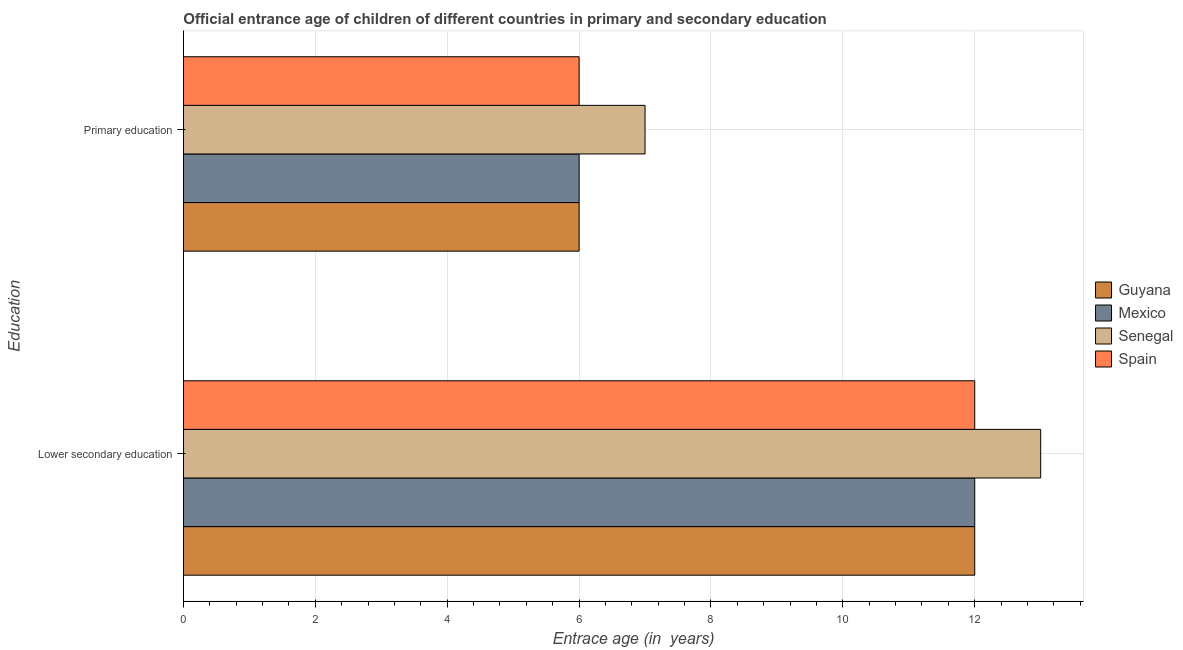How many groups of bars are there?
Offer a terse response. 2. Are the number of bars per tick equal to the number of legend labels?
Your response must be concise. Yes. What is the label of the 2nd group of bars from the top?
Provide a short and direct response. Lower secondary education. What is the entrance age of chiildren in primary education in Senegal?
Offer a terse response. 7. Across all countries, what is the maximum entrance age of children in lower secondary education?
Your answer should be compact. 13. Across all countries, what is the minimum entrance age of chiildren in primary education?
Ensure brevity in your answer.  6. In which country was the entrance age of chiildren in primary education maximum?
Your answer should be very brief. Senegal. In which country was the entrance age of chiildren in primary education minimum?
Make the answer very short. Guyana. What is the total entrance age of children in lower secondary education in the graph?
Your answer should be very brief. 49. What is the difference between the entrance age of children in lower secondary education in Mexico and that in Spain?
Offer a very short reply. 0. What is the difference between the entrance age of chiildren in primary education in Spain and the entrance age of children in lower secondary education in Senegal?
Make the answer very short. -7. What is the average entrance age of chiildren in primary education per country?
Offer a very short reply. 6.25. What is the difference between the entrance age of chiildren in primary education and entrance age of children in lower secondary education in Mexico?
Your answer should be very brief. -6. What is the ratio of the entrance age of chiildren in primary education in Senegal to that in Mexico?
Offer a terse response. 1.17. In how many countries, is the entrance age of children in lower secondary education greater than the average entrance age of children in lower secondary education taken over all countries?
Provide a short and direct response. 1. What does the 3rd bar from the top in Lower secondary education represents?
Offer a terse response. Mexico. What does the 3rd bar from the bottom in Lower secondary education represents?
Your answer should be compact. Senegal. How many bars are there?
Your answer should be compact. 8. Are all the bars in the graph horizontal?
Provide a short and direct response. Yes. How many countries are there in the graph?
Keep it short and to the point. 4. What is the difference between two consecutive major ticks on the X-axis?
Offer a terse response. 2. Are the values on the major ticks of X-axis written in scientific E-notation?
Provide a succinct answer. No. Does the graph contain any zero values?
Offer a very short reply. No. Does the graph contain grids?
Give a very brief answer. Yes. How are the legend labels stacked?
Provide a succinct answer. Vertical. What is the title of the graph?
Provide a short and direct response. Official entrance age of children of different countries in primary and secondary education. Does "Lesotho" appear as one of the legend labels in the graph?
Provide a succinct answer. No. What is the label or title of the X-axis?
Your response must be concise. Entrace age (in  years). What is the label or title of the Y-axis?
Keep it short and to the point. Education. What is the Entrace age (in  years) in Guyana in Lower secondary education?
Your response must be concise. 12. What is the Entrace age (in  years) of Spain in Lower secondary education?
Offer a terse response. 12. What is the Entrace age (in  years) in Guyana in Primary education?
Keep it short and to the point. 6. What is the Entrace age (in  years) of Senegal in Primary education?
Offer a terse response. 7. Across all Education, what is the maximum Entrace age (in  years) in Senegal?
Give a very brief answer. 13. Across all Education, what is the maximum Entrace age (in  years) of Spain?
Your answer should be very brief. 12. Across all Education, what is the minimum Entrace age (in  years) of Senegal?
Ensure brevity in your answer.  7. Across all Education, what is the minimum Entrace age (in  years) in Spain?
Your answer should be very brief. 6. What is the total Entrace age (in  years) in Mexico in the graph?
Your answer should be very brief. 18. What is the difference between the Entrace age (in  years) of Mexico in Lower secondary education and that in Primary education?
Keep it short and to the point. 6. What is the difference between the Entrace age (in  years) in Senegal in Lower secondary education and that in Primary education?
Ensure brevity in your answer.  6. What is the difference between the Entrace age (in  years) of Spain in Lower secondary education and that in Primary education?
Your answer should be compact. 6. What is the difference between the Entrace age (in  years) in Guyana in Lower secondary education and the Entrace age (in  years) in Senegal in Primary education?
Your response must be concise. 5. What is the difference between the Entrace age (in  years) of Guyana in Lower secondary education and the Entrace age (in  years) of Spain in Primary education?
Your answer should be very brief. 6. What is the difference between the Entrace age (in  years) of Mexico in Lower secondary education and the Entrace age (in  years) of Spain in Primary education?
Offer a terse response. 6. What is the difference between the Entrace age (in  years) of Senegal in Lower secondary education and the Entrace age (in  years) of Spain in Primary education?
Your answer should be compact. 7. What is the average Entrace age (in  years) in Spain per Education?
Give a very brief answer. 9. What is the difference between the Entrace age (in  years) of Guyana and Entrace age (in  years) of Mexico in Lower secondary education?
Your answer should be very brief. 0. What is the difference between the Entrace age (in  years) of Mexico and Entrace age (in  years) of Spain in Lower secondary education?
Offer a terse response. 0. What is the difference between the Entrace age (in  years) of Senegal and Entrace age (in  years) of Spain in Primary education?
Offer a very short reply. 1. What is the ratio of the Entrace age (in  years) in Senegal in Lower secondary education to that in Primary education?
Keep it short and to the point. 1.86. What is the difference between the highest and the second highest Entrace age (in  years) in Guyana?
Provide a succinct answer. 6. What is the difference between the highest and the second highest Entrace age (in  years) in Mexico?
Offer a very short reply. 6. What is the difference between the highest and the lowest Entrace age (in  years) of Guyana?
Offer a very short reply. 6. What is the difference between the highest and the lowest Entrace age (in  years) in Mexico?
Your response must be concise. 6. What is the difference between the highest and the lowest Entrace age (in  years) in Spain?
Provide a succinct answer. 6. 